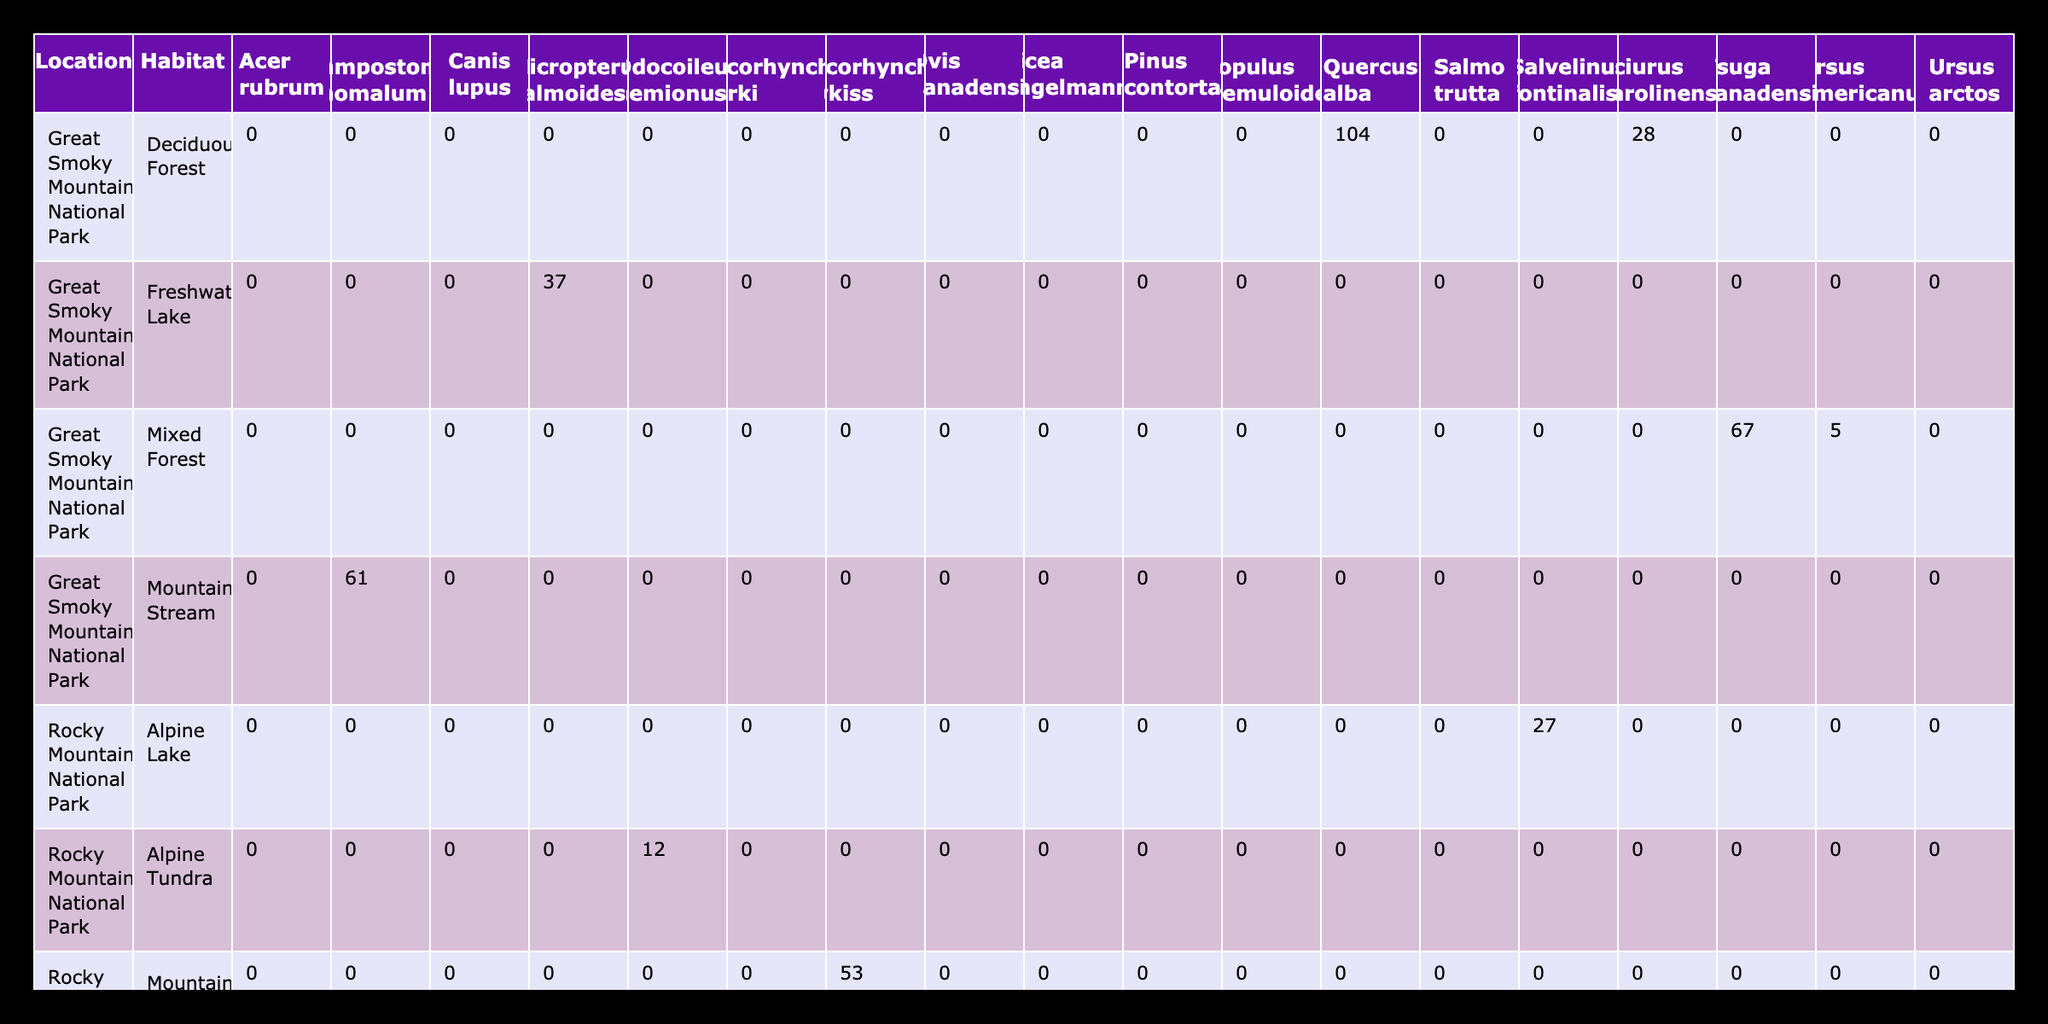What is the total count of species recorded in Yellowstone National Park? In the table, we can find the counts of various species recorded in Yellowstone National Park. By listing out the counts from the respective rows (127 for Acer rubrum, 89 for Pinus contorta, 3 for Ursus arctos, 7 for Canis lupus, 42 for Salmo trutta, and 31 for Oncorhynchus clarki) and adding them together, we get a total count of 299
Answer: 299 Which habitat in Rocky Mountain National Park had the highest species count? From the table, we examine the habitats listed under Rocky Mountain National Park. The counts are as follows: 156 for Subalpine Forest (Populus tremuloides), 78 for Subalpine Forest (Picea engelmannii), 12 for Alpine Tundra (Odocoileus hemionus), and 9 for Rocky Slopes (Ovis canadensis). The maximum count is 156 in the Subalpine Forest, which includes Populus tremuloides
Answer: 156 Is there a species that was recorded in both Yellowstone National Park and Rocky Mountain National Park? By checking the species listed in both parks, we notice that Salmo trutta is recorded in Yellowstone National Park and Oncorhynchus mykiss is recorded in Rocky Mountain National Park. However, no species appears in both locations; therefore, the answer is no
Answer: No What is the average count of species recorded in the Great Smoky Mountains National Park? The species counts recorded in the Great Smoky Mountains National Park are 104 (Quercus alba), 67 (Tsuga canadensis), 5 (Ursus americanus), 28 (Sciurus carolinensis), 37 (Micropterus salmoides), and 61 (Campostoma anomalum). Adding these counts gives us a total of 302, and since there are 6 species, the average count is calculated as 302 divided by 6, which equals approximately 50.33
Answer: 50.33 What is the species count difference between Yellowstone National Park and Rocky Mountain National Park? To calculate the species count difference, first, find the total counts for each park. Yellowstone National Park has a total count of 299, while Rocky Mountain National Park has totals of 156 (Populus tremuloides) + 78 (Picea engelmannii) + 12 (Odocoileus hemionus) + 9 (Ovis canadensis) + 53 (Oncorhynchus mykiss) + 27 (Salvelinus fontinalis) = 335. The difference is 335 - 299 = 36
Answer: 36 What method was used by the most researchers to survey in Yellowstone National Park? The survey methods listed for Yellowstone National Park are Quadrat Sampling (used by Emily Johnson), Point-Quarter Method (also by Emily Johnson), Camera Trapping (by Michael Lee), Transect Survey (by Michael Lee), Electrofishing (by Sarah Martinez), and Gill Netting (by Sarah Martinez). Quadrant Sampling and Point-Quarter Method were the most common methods, both employed twice by Emily Johnson
Answer: Quadrat Sampling and Point-Quarter Method 